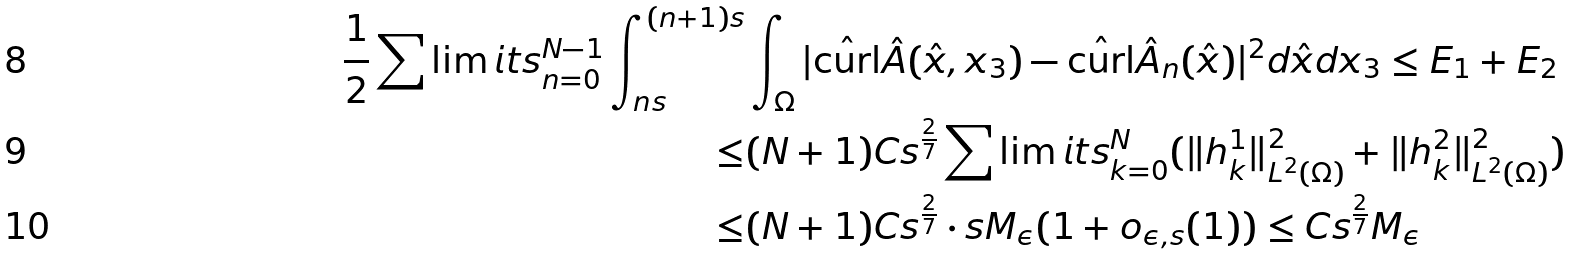Convert formula to latex. <formula><loc_0><loc_0><loc_500><loc_500>\frac { 1 } { 2 } \sum \lim i t s _ { n = 0 } ^ { N - 1 } \int _ { n s } ^ { ( n + 1 ) s } & \int _ { \Omega } | \hat { \text {curl} } \hat { A } ( \hat { x } , x _ { 3 } ) - \hat { \text {curl} } \hat { A } _ { n } ( \hat { x } ) | ^ { 2 } d \hat { x } d x _ { 3 } \leq E _ { 1 } + E _ { 2 } \\ \leq & ( N + 1 ) C s ^ { \frac { 2 } { 7 } } \sum \lim i t s _ { k = 0 } ^ { N } ( \| h ^ { 1 } _ { k } \| ^ { 2 } _ { L ^ { 2 } ( \Omega ) } + \| h ^ { 2 } _ { k } \| ^ { 2 } _ { L ^ { 2 } ( \Omega ) } ) \\ \leq & ( N + 1 ) C s ^ { \frac { 2 } { 7 } } \cdot s M _ { \epsilon } ( 1 + o _ { \epsilon , s } ( 1 ) ) \leq C s ^ { \frac { 2 } { 7 } } M _ { \epsilon }</formula> 